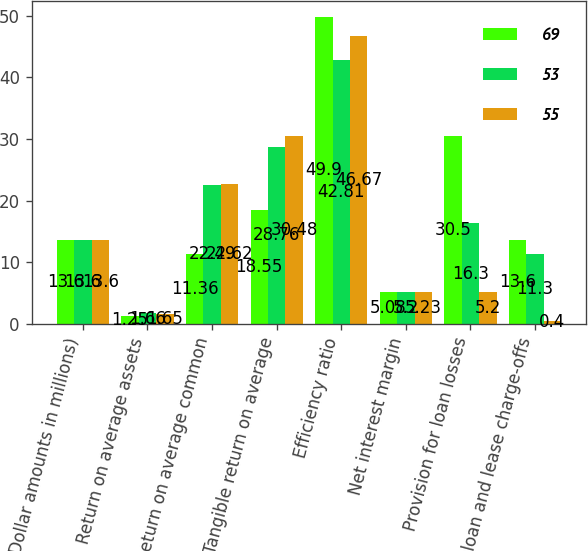Convert chart. <chart><loc_0><loc_0><loc_500><loc_500><stacked_bar_chart><ecel><fcel>(Dollar amounts in millions)<fcel>Return on average assets<fcel>Return on average common<fcel>Tangible return on average<fcel>Efficiency ratio<fcel>Net interest margin<fcel>Provision for loan losses<fcel>Net loan and lease charge-offs<nl><fcel>69<fcel>13.6<fcel>1.25<fcel>11.36<fcel>18.55<fcel>49.9<fcel>5.08<fcel>30.5<fcel>13.6<nl><fcel>53<fcel>13.6<fcel>1.66<fcel>22.49<fcel>28.76<fcel>42.81<fcel>5.2<fcel>16.3<fcel>11.3<nl><fcel>55<fcel>13.6<fcel>1.65<fcel>22.62<fcel>30.48<fcel>46.67<fcel>5.23<fcel>5.2<fcel>0.4<nl></chart> 